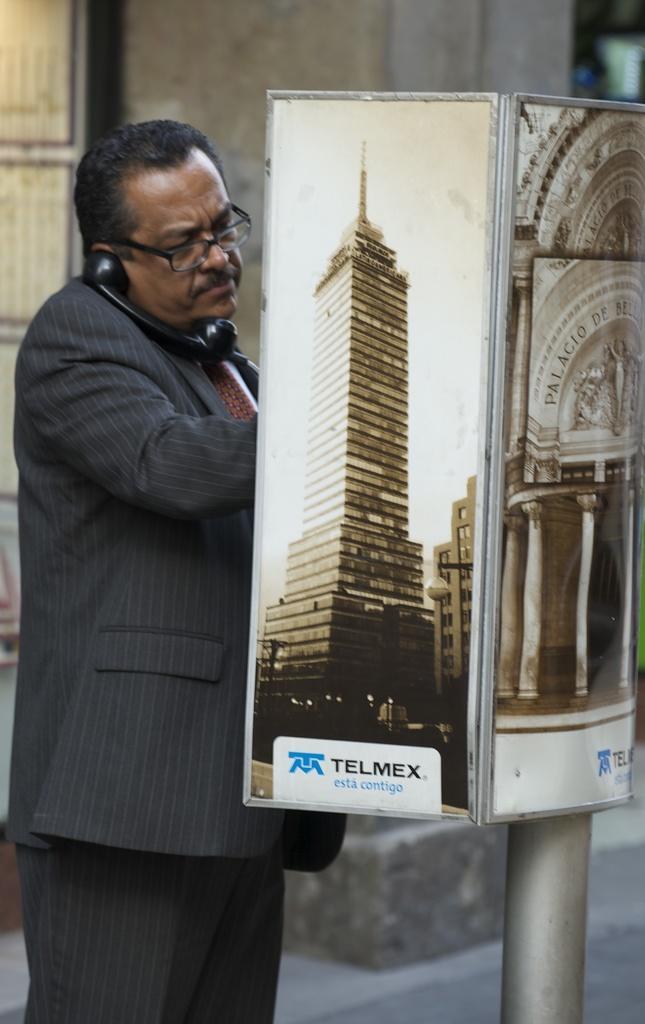Please provide a concise description of this image. Here in this picture we can see a man wearing a suit and standing over a place and in front of him we can see a telephone present on a pole, that is covered with boards and on that boards we can see buildings present and we can see the man is holding the telephone near to his ears and he is also wearing spectacles. 